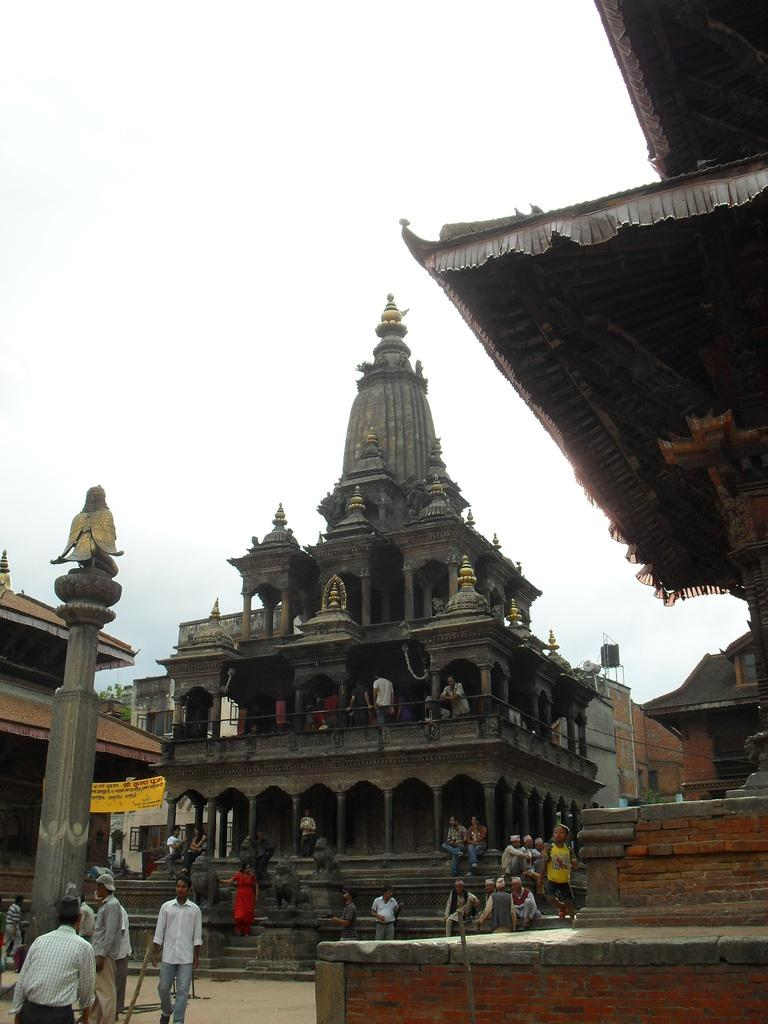What is the main structure in the center of the image? There is a temple in the center of the image. What can be seen on the left side of the image? There is a pole on the left side of the image. What else is present in the center of the image besides the temple? There are people in the center of the image. What type of rail is visible in the image? There is no rail present in the image. Can you tell me the relationship between the people and the temple in the image? The provided facts do not mention any specific relationships between the people and the temple. 